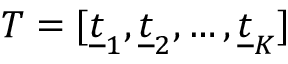Convert formula to latex. <formula><loc_0><loc_0><loc_500><loc_500>T = [ \underline { t } _ { 1 } , \underline { t } _ { 2 } , \dots , \underline { t } _ { K } ]</formula> 